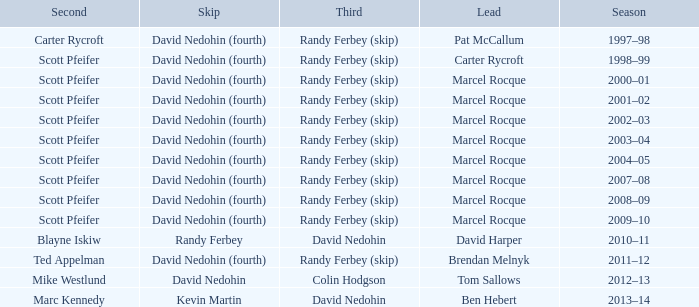Which Lead has a Third of randy ferbey (skip), a Second of scott pfeifer, and a Season of 2009–10? Marcel Rocque. 